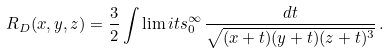<formula> <loc_0><loc_0><loc_500><loc_500>R _ { D } ( x , y , z ) = \frac { 3 } { 2 } \int \lim i t s _ { 0 } ^ { \infty } \, \frac { d t } { \sqrt { ( x + t ) ( y + t ) ( z + t ) ^ { 3 } } } \, .</formula> 